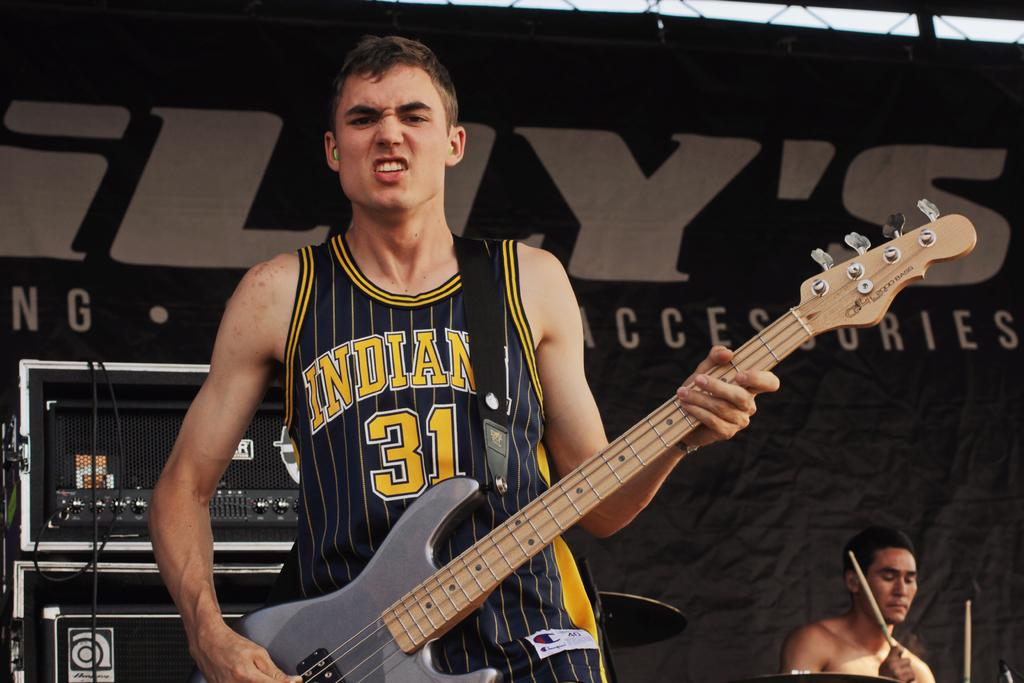Provide a one-sentence caption for the provided image. A man holding a guitar in a jersey that is black and in yellow letters says Indiana 31. 